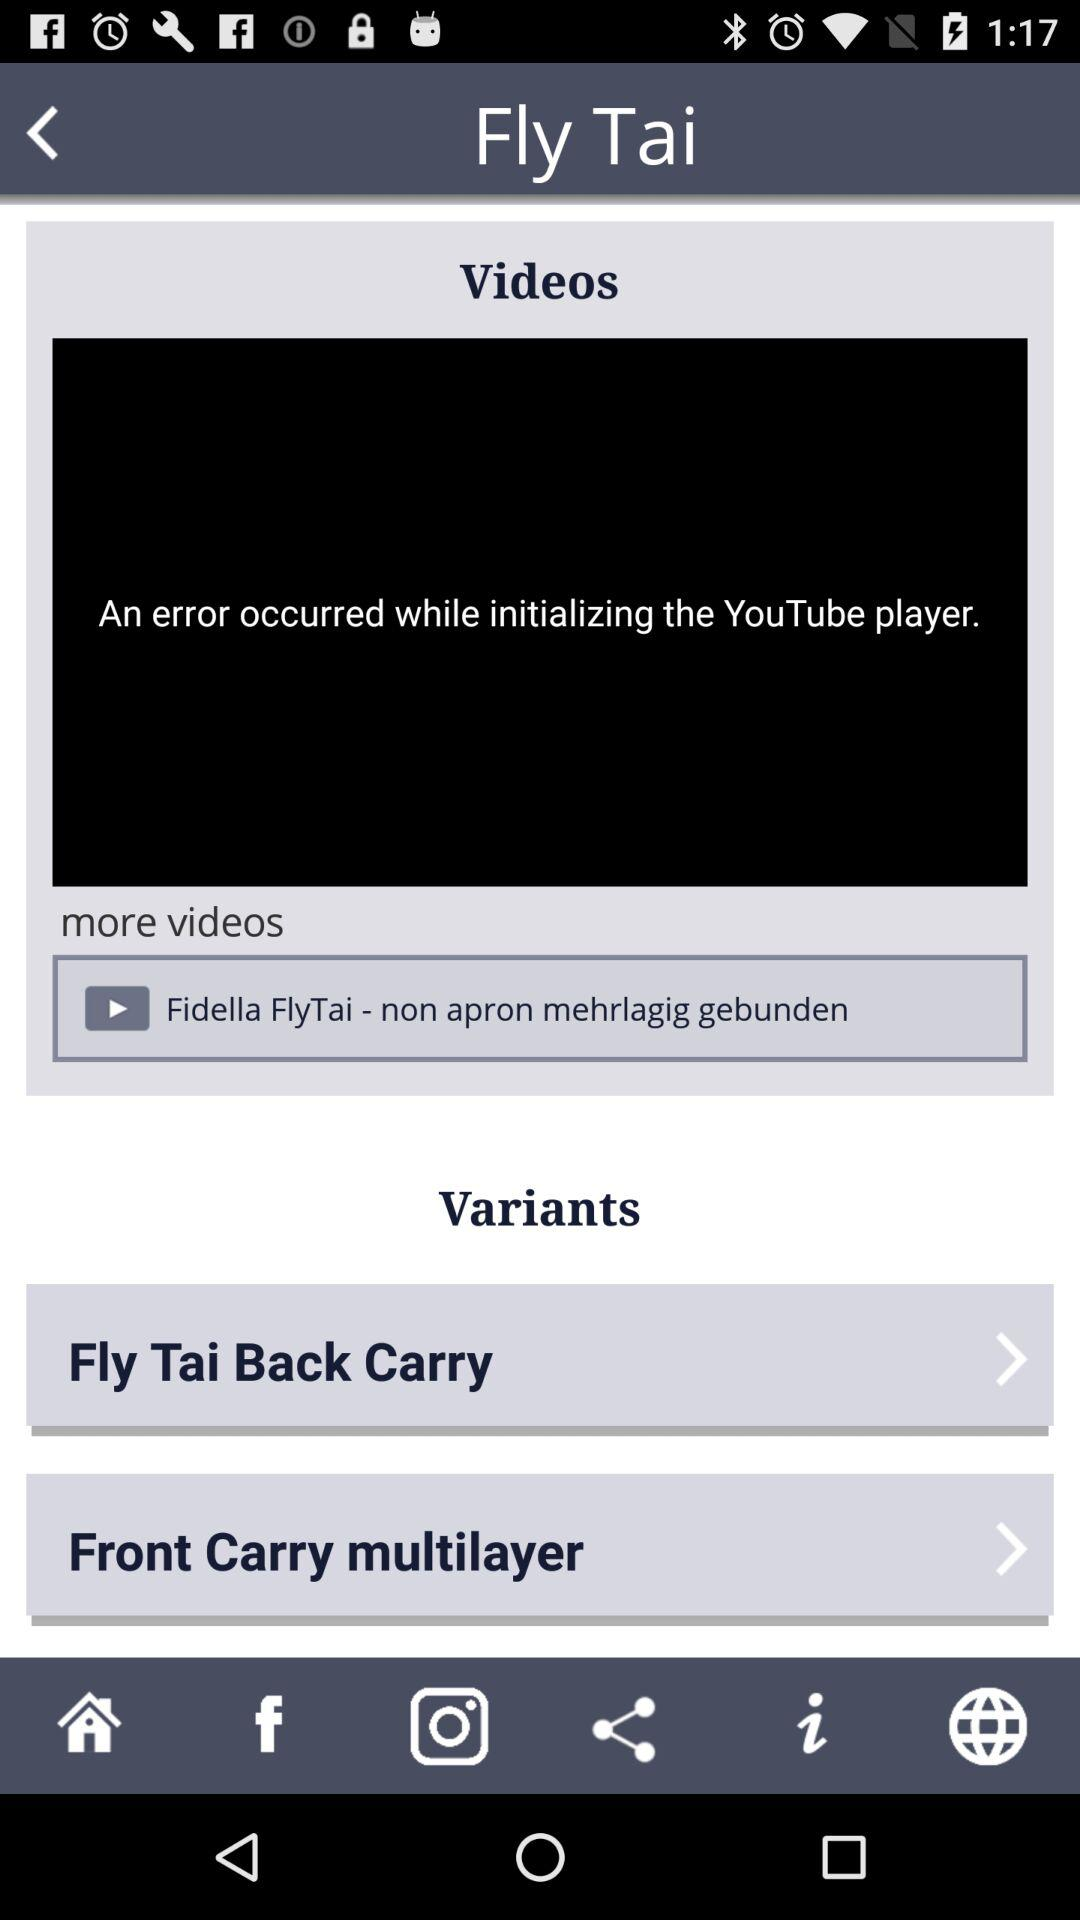What is the name of the application?
When the provided information is insufficient, respond with <no answer>. <no answer> 